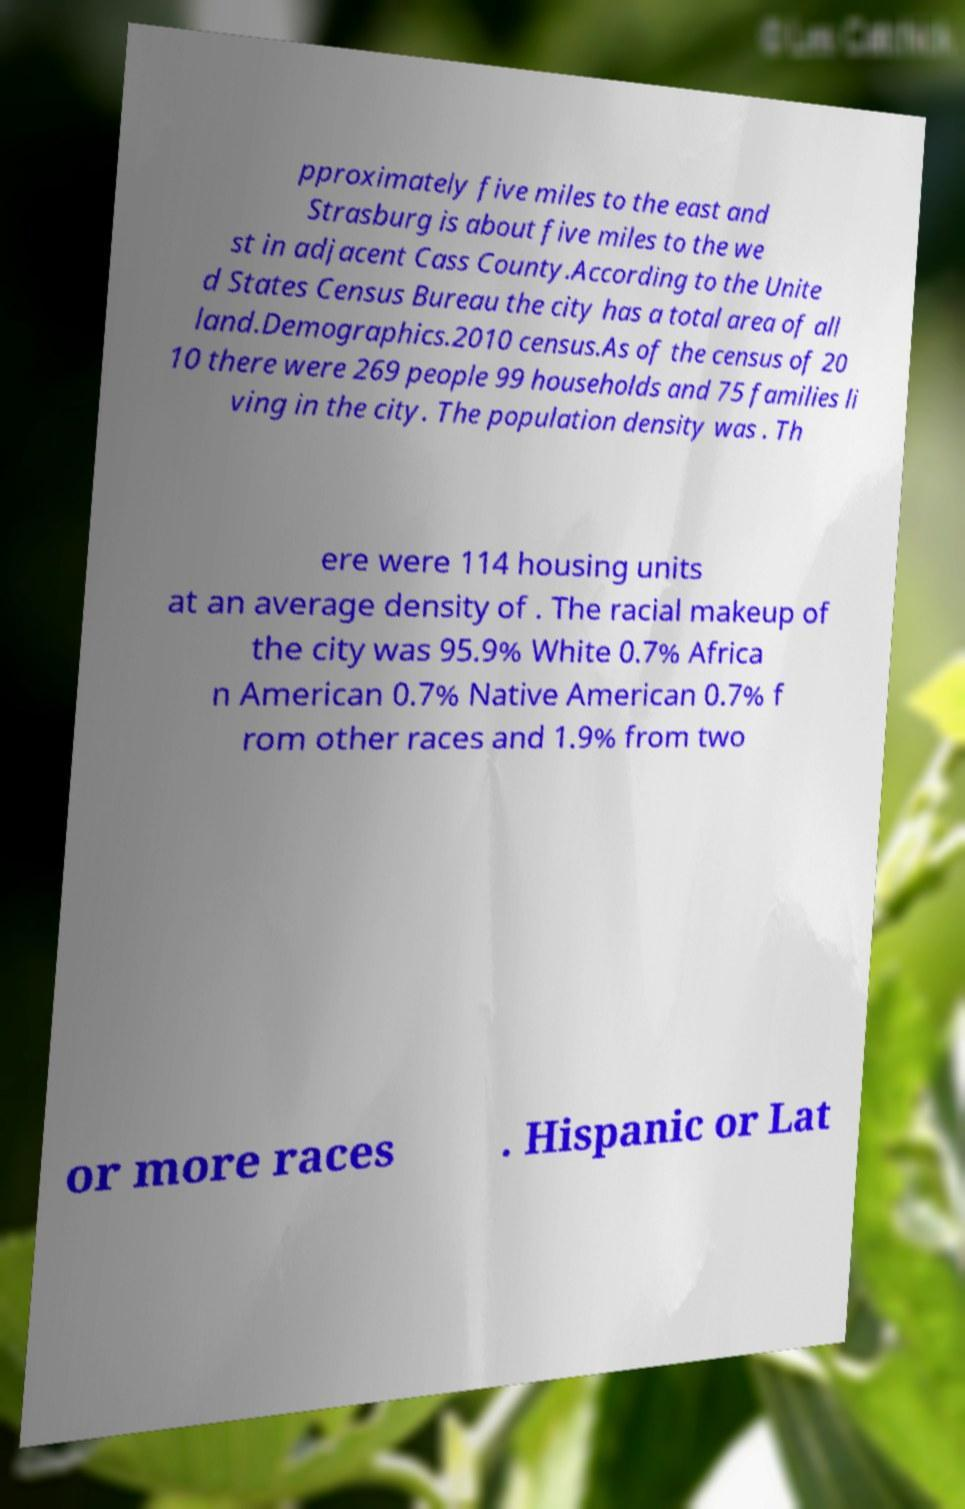Could you extract and type out the text from this image? pproximately five miles to the east and Strasburg is about five miles to the we st in adjacent Cass County.According to the Unite d States Census Bureau the city has a total area of all land.Demographics.2010 census.As of the census of 20 10 there were 269 people 99 households and 75 families li ving in the city. The population density was . Th ere were 114 housing units at an average density of . The racial makeup of the city was 95.9% White 0.7% Africa n American 0.7% Native American 0.7% f rom other races and 1.9% from two or more races . Hispanic or Lat 